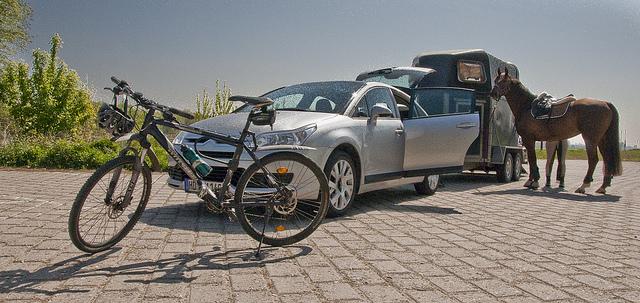What animal is pulling the carriage?
Keep it brief. Horse. What color scheme was the photo taken in?
Short answer required. Color. Is this a modern vehicle?
Answer briefly. Yes. Are the horses going to follow a trail?
Keep it brief. No. What is in the wagon?
Write a very short answer. Horse. What is the player doing?
Give a very brief answer. Saddling horse. Is this a park scene?
Answer briefly. No. Does the horse have any shade?
Give a very brief answer. No. What is the white covered on the bike seat?
Give a very brief answer. Leather. What color is the horse?
Concise answer only. Brown. What is in the basket of the bicycle?
Answer briefly. Helmet. What is the gold and black structure?
Be succinct. Trailer. Are the going to transport the horse?
Quick response, please. Yes. Which moving object can move fastest?
Be succinct. Car. What is the horse looking over?
Keep it brief. Car. Is the owner of the car and bike the same?
Keep it brief. Yes. 